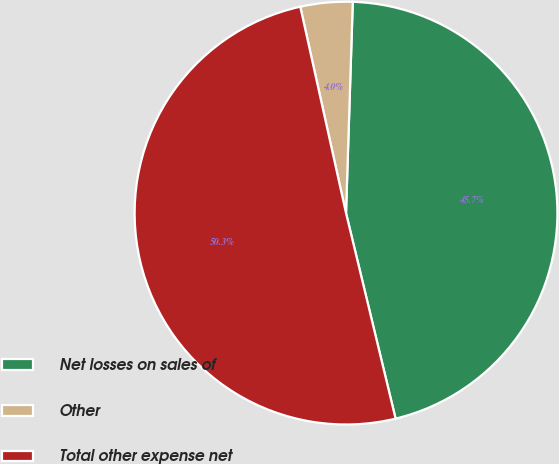Convert chart. <chart><loc_0><loc_0><loc_500><loc_500><pie_chart><fcel>Net losses on sales of<fcel>Other<fcel>Total other expense net<nl><fcel>45.72%<fcel>3.98%<fcel>50.29%<nl></chart> 